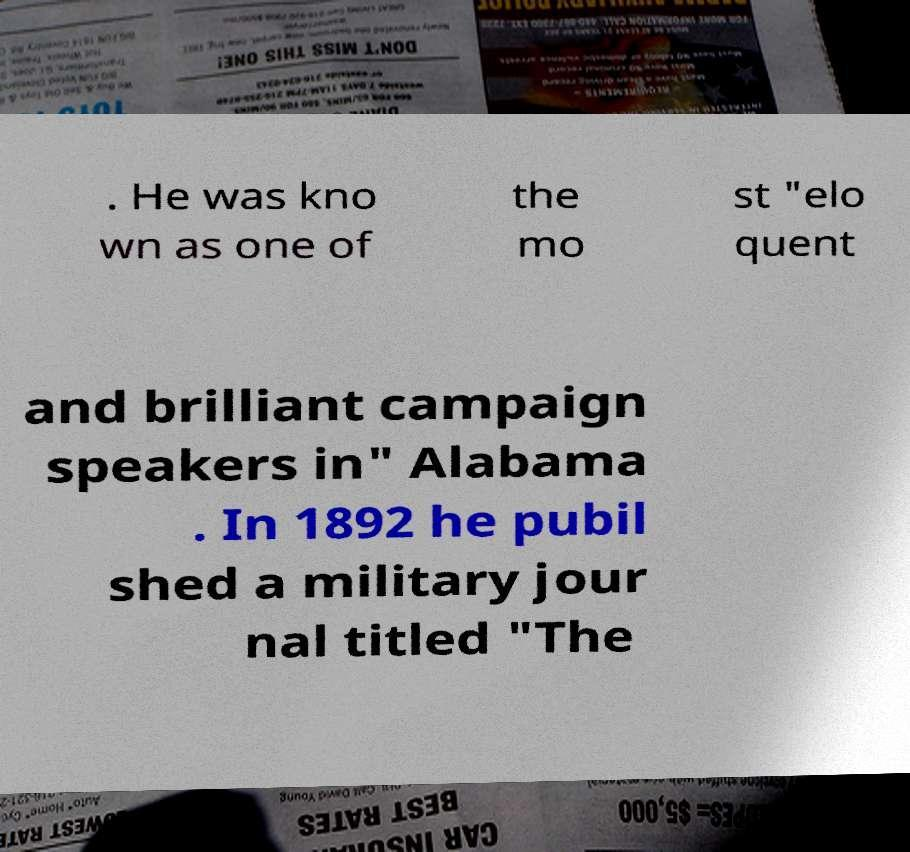Could you extract and type out the text from this image? . He was kno wn as one of the mo st "elo quent and brilliant campaign speakers in" Alabama . In 1892 he pubil shed a military jour nal titled "The 